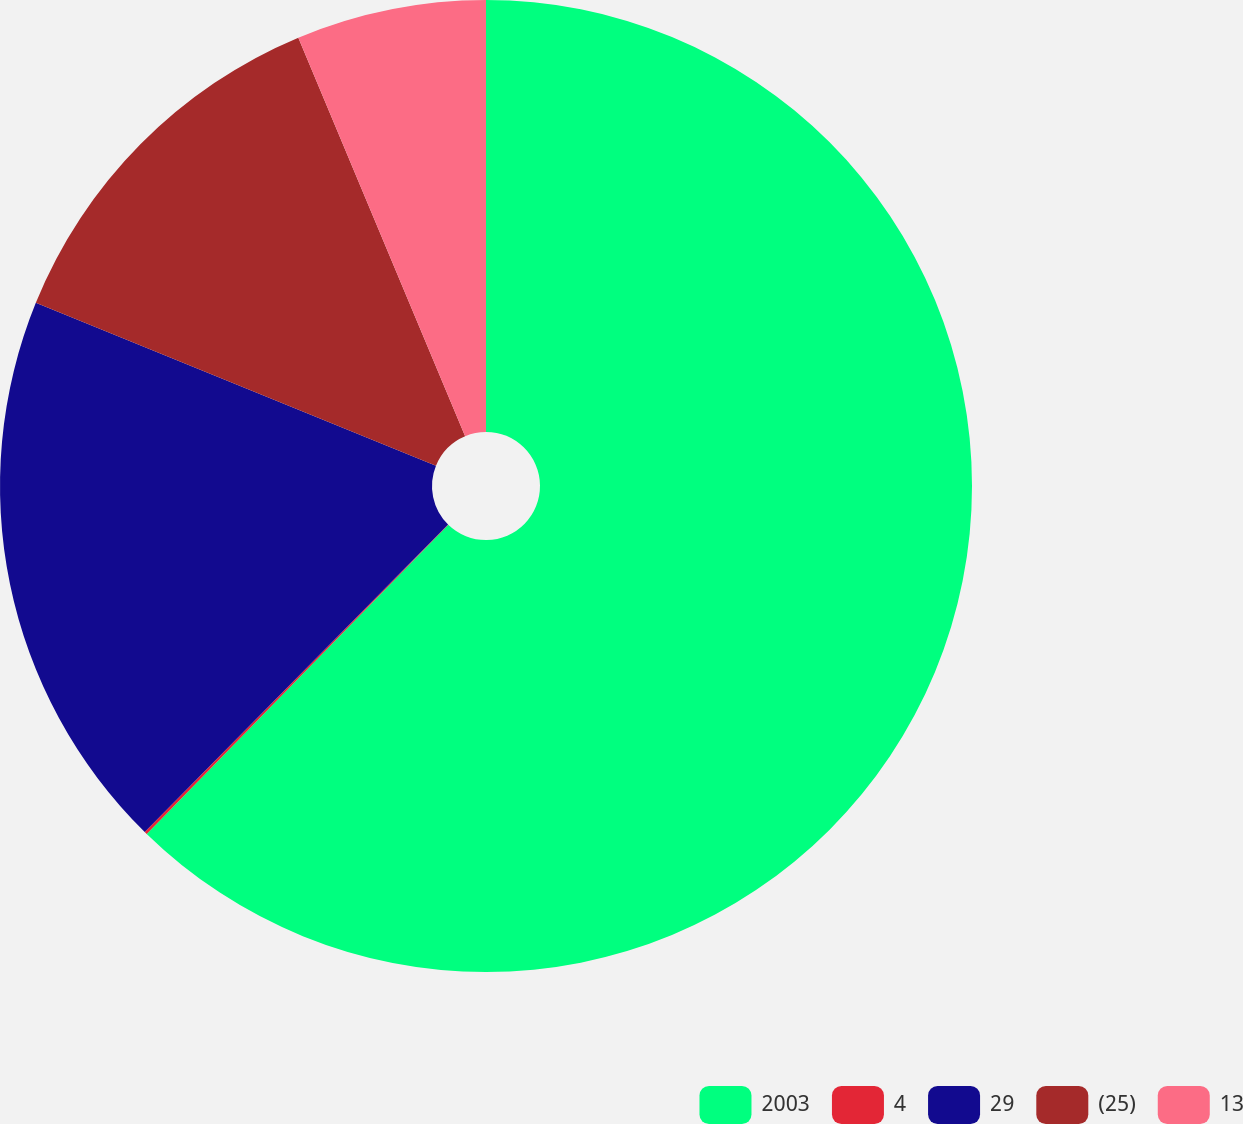<chart> <loc_0><loc_0><loc_500><loc_500><pie_chart><fcel>2003<fcel>4<fcel>29<fcel>(25)<fcel>13<nl><fcel>62.3%<fcel>0.09%<fcel>18.76%<fcel>12.54%<fcel>6.31%<nl></chart> 